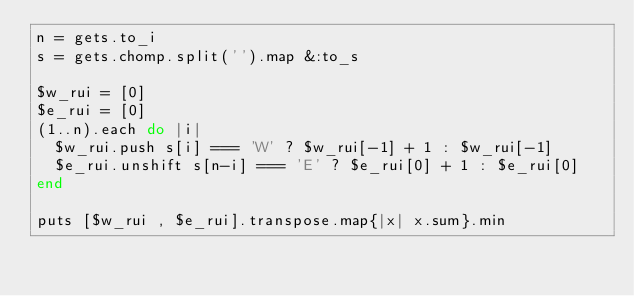Convert code to text. <code><loc_0><loc_0><loc_500><loc_500><_Ruby_>n = gets.to_i
s = gets.chomp.split('').map &:to_s

$w_rui = [0]
$e_rui = [0]
(1..n).each do |i|
  $w_rui.push s[i] === 'W' ? $w_rui[-1] + 1 : $w_rui[-1]
  $e_rui.unshift s[n-i] === 'E' ? $e_rui[0] + 1 : $e_rui[0]
end

puts [$w_rui , $e_rui].transpose.map{|x| x.sum}.min


</code> 